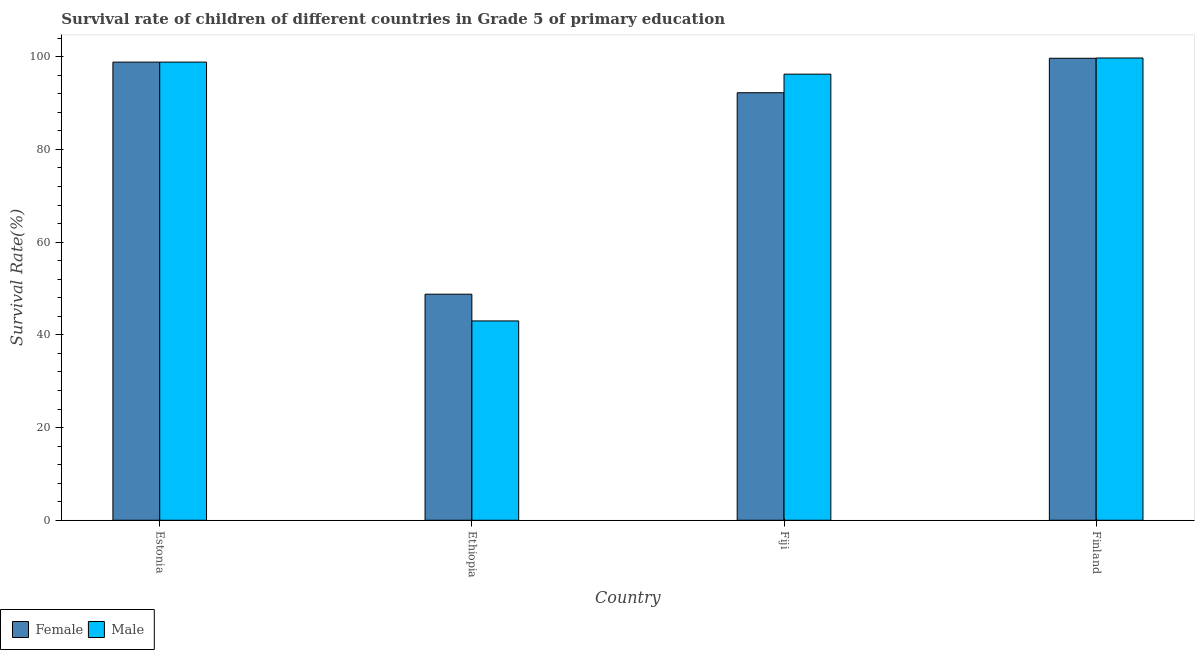Are the number of bars on each tick of the X-axis equal?
Ensure brevity in your answer.  Yes. How many bars are there on the 4th tick from the left?
Give a very brief answer. 2. What is the label of the 3rd group of bars from the left?
Provide a succinct answer. Fiji. What is the survival rate of male students in primary education in Ethiopia?
Offer a terse response. 43. Across all countries, what is the maximum survival rate of female students in primary education?
Offer a terse response. 99.66. Across all countries, what is the minimum survival rate of male students in primary education?
Give a very brief answer. 43. In which country was the survival rate of male students in primary education maximum?
Make the answer very short. Finland. In which country was the survival rate of male students in primary education minimum?
Give a very brief answer. Ethiopia. What is the total survival rate of female students in primary education in the graph?
Provide a succinct answer. 339.47. What is the difference between the survival rate of female students in primary education in Ethiopia and that in Finland?
Offer a very short reply. -50.89. What is the difference between the survival rate of male students in primary education in Fiji and the survival rate of female students in primary education in Estonia?
Ensure brevity in your answer.  -2.59. What is the average survival rate of male students in primary education per country?
Make the answer very short. 84.44. What is the difference between the survival rate of female students in primary education and survival rate of male students in primary education in Fiji?
Keep it short and to the point. -4.01. What is the ratio of the survival rate of female students in primary education in Ethiopia to that in Finland?
Your answer should be very brief. 0.49. Is the survival rate of male students in primary education in Ethiopia less than that in Finland?
Provide a short and direct response. Yes. Is the difference between the survival rate of female students in primary education in Fiji and Finland greater than the difference between the survival rate of male students in primary education in Fiji and Finland?
Your answer should be compact. No. What is the difference between the highest and the second highest survival rate of male students in primary education?
Offer a terse response. 0.89. What is the difference between the highest and the lowest survival rate of female students in primary education?
Your answer should be very brief. 50.89. In how many countries, is the survival rate of male students in primary education greater than the average survival rate of male students in primary education taken over all countries?
Offer a terse response. 3. Is the sum of the survival rate of male students in primary education in Estonia and Ethiopia greater than the maximum survival rate of female students in primary education across all countries?
Your answer should be very brief. Yes. What does the 1st bar from the right in Ethiopia represents?
Make the answer very short. Male. How many bars are there?
Keep it short and to the point. 8. Are all the bars in the graph horizontal?
Your response must be concise. No. Are the values on the major ticks of Y-axis written in scientific E-notation?
Provide a succinct answer. No. Does the graph contain any zero values?
Provide a short and direct response. No. Where does the legend appear in the graph?
Give a very brief answer. Bottom left. How many legend labels are there?
Provide a short and direct response. 2. What is the title of the graph?
Offer a terse response. Survival rate of children of different countries in Grade 5 of primary education. Does "Chemicals" appear as one of the legend labels in the graph?
Give a very brief answer. No. What is the label or title of the Y-axis?
Offer a very short reply. Survival Rate(%). What is the Survival Rate(%) of Female in Estonia?
Provide a short and direct response. 98.83. What is the Survival Rate(%) of Male in Estonia?
Make the answer very short. 98.83. What is the Survival Rate(%) in Female in Ethiopia?
Make the answer very short. 48.77. What is the Survival Rate(%) of Male in Ethiopia?
Keep it short and to the point. 43. What is the Survival Rate(%) in Female in Fiji?
Give a very brief answer. 92.22. What is the Survival Rate(%) in Male in Fiji?
Keep it short and to the point. 96.23. What is the Survival Rate(%) in Female in Finland?
Your answer should be compact. 99.66. What is the Survival Rate(%) in Male in Finland?
Make the answer very short. 99.72. Across all countries, what is the maximum Survival Rate(%) of Female?
Offer a terse response. 99.66. Across all countries, what is the maximum Survival Rate(%) of Male?
Your response must be concise. 99.72. Across all countries, what is the minimum Survival Rate(%) in Female?
Offer a terse response. 48.77. Across all countries, what is the minimum Survival Rate(%) of Male?
Your response must be concise. 43. What is the total Survival Rate(%) in Female in the graph?
Your answer should be compact. 339.47. What is the total Survival Rate(%) in Male in the graph?
Your answer should be very brief. 337.78. What is the difference between the Survival Rate(%) of Female in Estonia and that in Ethiopia?
Offer a very short reply. 50.06. What is the difference between the Survival Rate(%) in Male in Estonia and that in Ethiopia?
Provide a succinct answer. 55.83. What is the difference between the Survival Rate(%) in Female in Estonia and that in Fiji?
Provide a succinct answer. 6.6. What is the difference between the Survival Rate(%) of Male in Estonia and that in Fiji?
Provide a short and direct response. 2.6. What is the difference between the Survival Rate(%) of Female in Estonia and that in Finland?
Provide a short and direct response. -0.83. What is the difference between the Survival Rate(%) in Male in Estonia and that in Finland?
Keep it short and to the point. -0.89. What is the difference between the Survival Rate(%) of Female in Ethiopia and that in Fiji?
Your response must be concise. -43.46. What is the difference between the Survival Rate(%) of Male in Ethiopia and that in Fiji?
Your answer should be compact. -53.23. What is the difference between the Survival Rate(%) of Female in Ethiopia and that in Finland?
Ensure brevity in your answer.  -50.89. What is the difference between the Survival Rate(%) of Male in Ethiopia and that in Finland?
Ensure brevity in your answer.  -56.72. What is the difference between the Survival Rate(%) of Female in Fiji and that in Finland?
Your answer should be very brief. -7.43. What is the difference between the Survival Rate(%) of Male in Fiji and that in Finland?
Your response must be concise. -3.49. What is the difference between the Survival Rate(%) in Female in Estonia and the Survival Rate(%) in Male in Ethiopia?
Your answer should be very brief. 55.83. What is the difference between the Survival Rate(%) in Female in Estonia and the Survival Rate(%) in Male in Fiji?
Give a very brief answer. 2.59. What is the difference between the Survival Rate(%) of Female in Estonia and the Survival Rate(%) of Male in Finland?
Offer a terse response. -0.89. What is the difference between the Survival Rate(%) in Female in Ethiopia and the Survival Rate(%) in Male in Fiji?
Offer a very short reply. -47.46. What is the difference between the Survival Rate(%) in Female in Ethiopia and the Survival Rate(%) in Male in Finland?
Keep it short and to the point. -50.95. What is the difference between the Survival Rate(%) of Female in Fiji and the Survival Rate(%) of Male in Finland?
Provide a succinct answer. -7.49. What is the average Survival Rate(%) of Female per country?
Provide a short and direct response. 84.87. What is the average Survival Rate(%) in Male per country?
Offer a very short reply. 84.44. What is the difference between the Survival Rate(%) in Female and Survival Rate(%) in Male in Estonia?
Ensure brevity in your answer.  -0.01. What is the difference between the Survival Rate(%) in Female and Survival Rate(%) in Male in Ethiopia?
Give a very brief answer. 5.77. What is the difference between the Survival Rate(%) of Female and Survival Rate(%) of Male in Fiji?
Your answer should be compact. -4.01. What is the difference between the Survival Rate(%) in Female and Survival Rate(%) in Male in Finland?
Offer a very short reply. -0.06. What is the ratio of the Survival Rate(%) of Female in Estonia to that in Ethiopia?
Keep it short and to the point. 2.03. What is the ratio of the Survival Rate(%) in Male in Estonia to that in Ethiopia?
Make the answer very short. 2.3. What is the ratio of the Survival Rate(%) of Female in Estonia to that in Fiji?
Provide a succinct answer. 1.07. What is the ratio of the Survival Rate(%) of Male in Estonia to that in Fiji?
Offer a very short reply. 1.03. What is the ratio of the Survival Rate(%) of Female in Estonia to that in Finland?
Keep it short and to the point. 0.99. What is the ratio of the Survival Rate(%) of Female in Ethiopia to that in Fiji?
Your answer should be very brief. 0.53. What is the ratio of the Survival Rate(%) of Male in Ethiopia to that in Fiji?
Offer a terse response. 0.45. What is the ratio of the Survival Rate(%) in Female in Ethiopia to that in Finland?
Keep it short and to the point. 0.49. What is the ratio of the Survival Rate(%) of Male in Ethiopia to that in Finland?
Offer a terse response. 0.43. What is the ratio of the Survival Rate(%) of Female in Fiji to that in Finland?
Offer a terse response. 0.93. What is the difference between the highest and the second highest Survival Rate(%) of Female?
Your answer should be compact. 0.83. What is the difference between the highest and the second highest Survival Rate(%) in Male?
Your answer should be very brief. 0.89. What is the difference between the highest and the lowest Survival Rate(%) in Female?
Your response must be concise. 50.89. What is the difference between the highest and the lowest Survival Rate(%) in Male?
Provide a succinct answer. 56.72. 